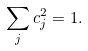Convert formula to latex. <formula><loc_0><loc_0><loc_500><loc_500>\sum _ { j } c _ { j } ^ { 2 } = 1 .</formula> 